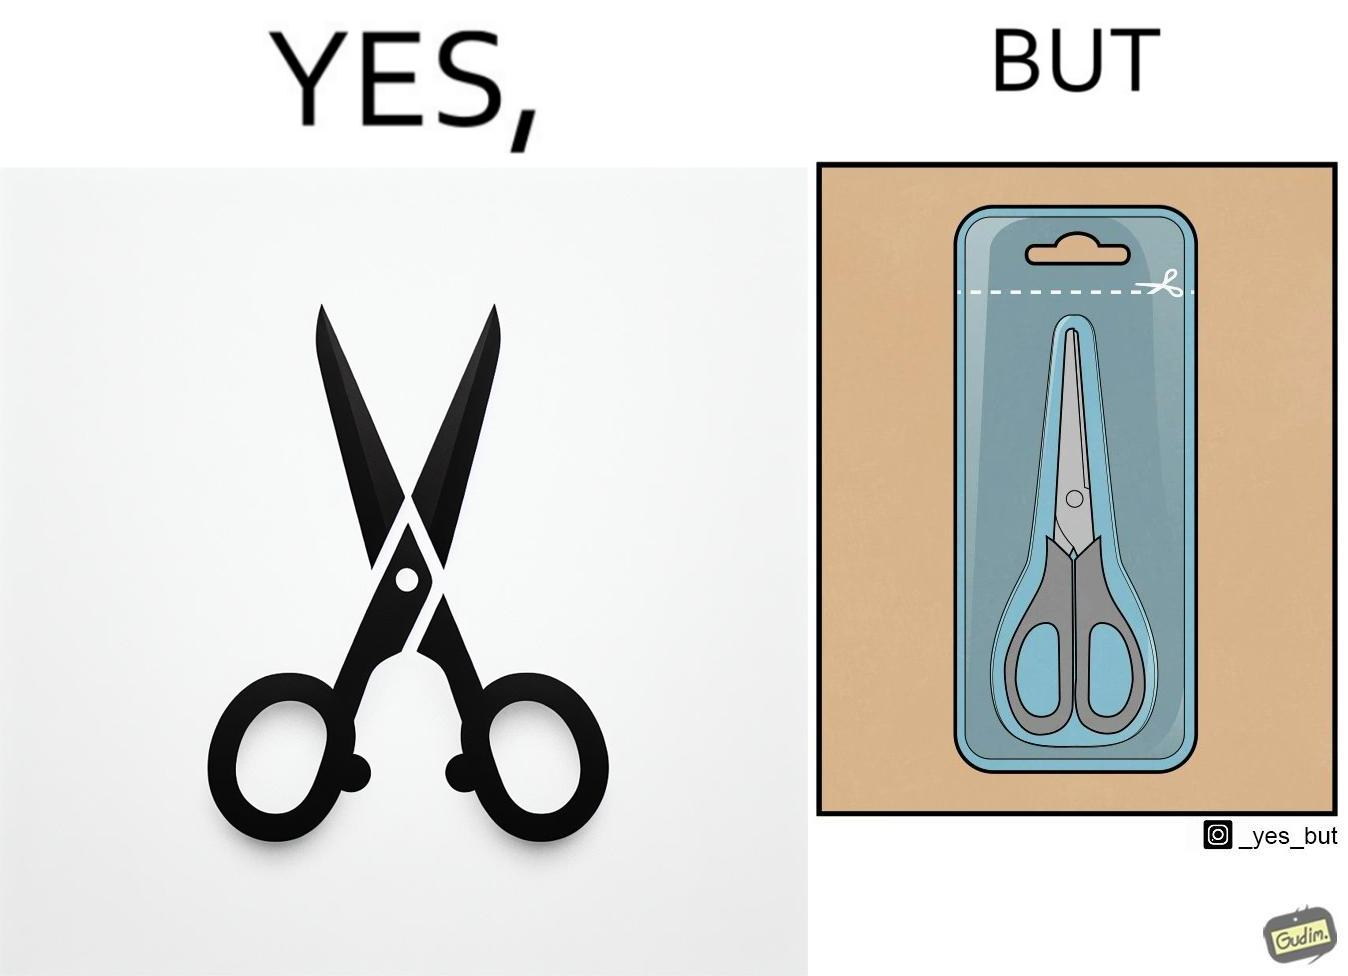Does this image contain satire or humor? Yes, this image is satirical. 